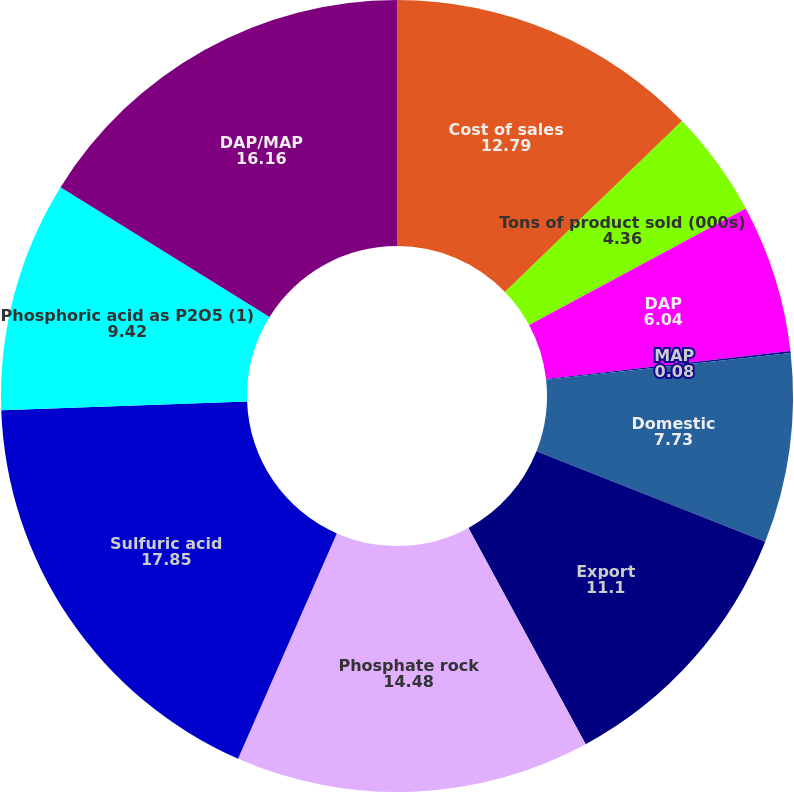Convert chart to OTSL. <chart><loc_0><loc_0><loc_500><loc_500><pie_chart><fcel>Cost of sales<fcel>Tons of product sold (000s)<fcel>DAP<fcel>MAP<fcel>Domestic<fcel>Export<fcel>Phosphate rock<fcel>Sulfuric acid<fcel>Phosphoric acid as P2O5 (1)<fcel>DAP/MAP<nl><fcel>12.79%<fcel>4.36%<fcel>6.04%<fcel>0.08%<fcel>7.73%<fcel>11.1%<fcel>14.48%<fcel>17.85%<fcel>9.42%<fcel>16.16%<nl></chart> 